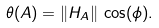Convert formula to latex. <formula><loc_0><loc_0><loc_500><loc_500>\theta ( A ) = \| H _ { A } \| \, \cos ( \phi ) .</formula> 